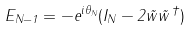<formula> <loc_0><loc_0><loc_500><loc_500>E _ { N - 1 } = - e ^ { i \theta _ { N } } ( I _ { N } - 2 \vec { w } \vec { w } ^ { \, \dagger } )</formula> 